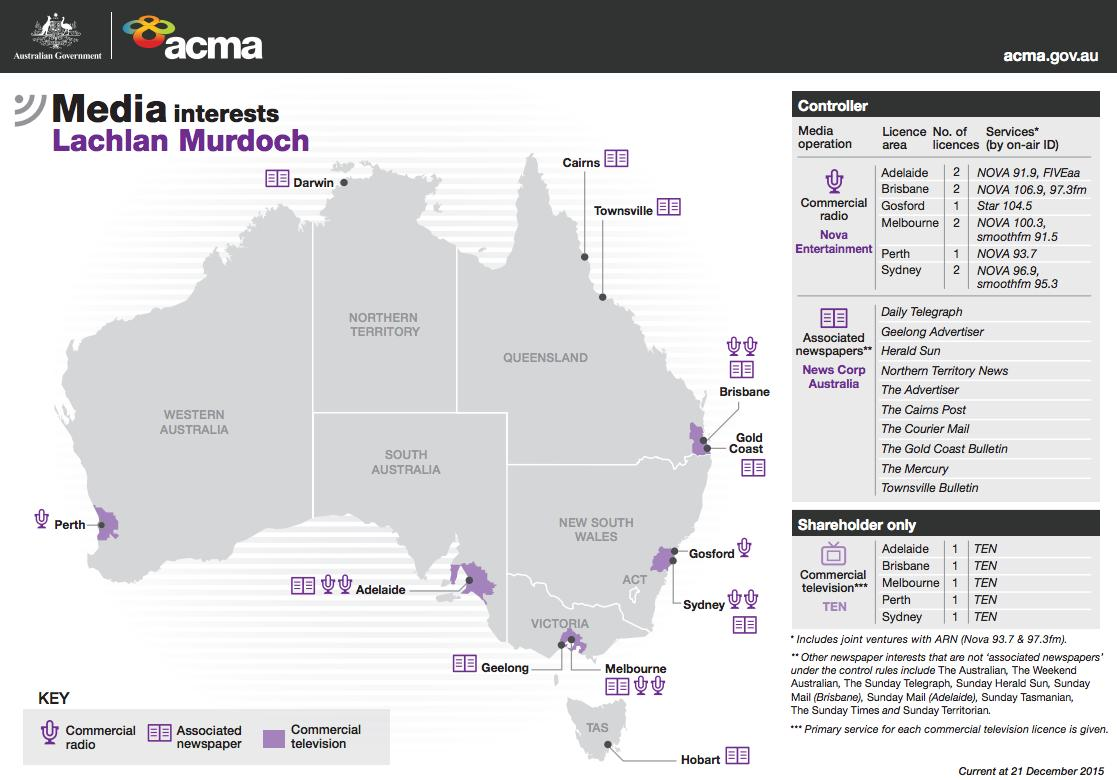Outline some significant characteristics in this image. Commercial radio and television are interested in Perth. The media outlets that are interested in the Gold Coast are the Associated newspaper and commercial television. There are approximately 10 newspapers available in Australia. It is estimated that three media outlets are interested in Brisbane. Hobart is of interest to various forms of media, including newspapers. 